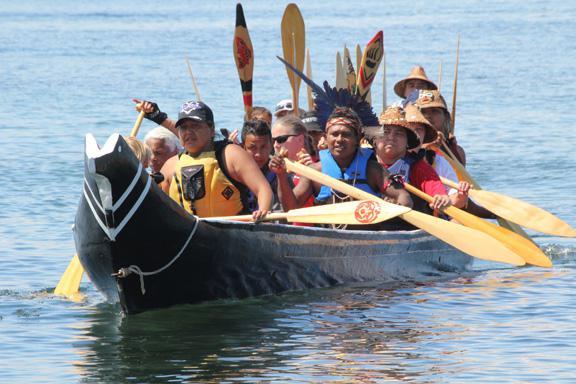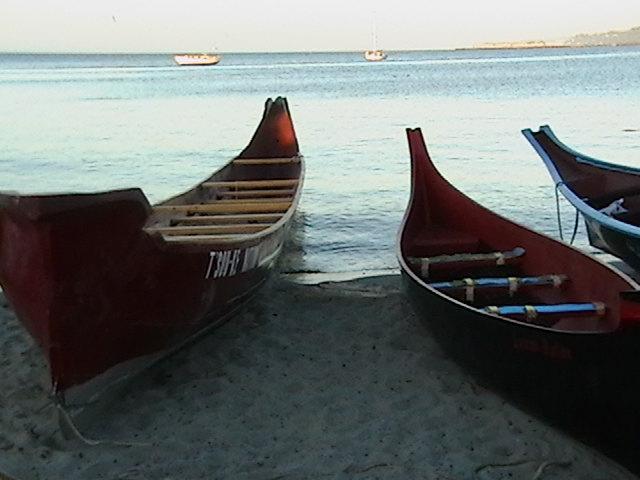The first image is the image on the left, the second image is the image on the right. Analyze the images presented: Is the assertion "An image shows the tips of at least two reddish-brown boats that are pulled to shore and overlooking the water." valid? Answer yes or no. Yes. The first image is the image on the left, the second image is the image on the right. For the images displayed, is the sentence "In at least one image there are at least three empty boats." factually correct? Answer yes or no. Yes. 